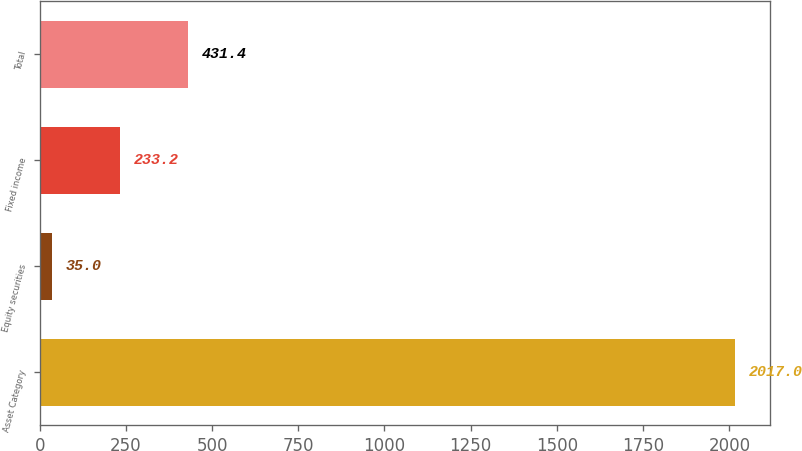Convert chart. <chart><loc_0><loc_0><loc_500><loc_500><bar_chart><fcel>Asset Category<fcel>Equity securities<fcel>Fixed income<fcel>Total<nl><fcel>2017<fcel>35<fcel>233.2<fcel>431.4<nl></chart> 